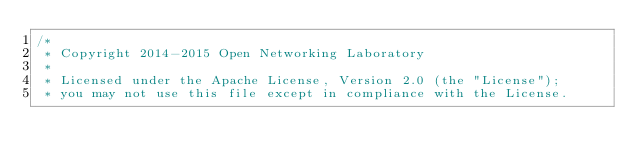<code> <loc_0><loc_0><loc_500><loc_500><_Java_>/*
 * Copyright 2014-2015 Open Networking Laboratory
 *
 * Licensed under the Apache License, Version 2.0 (the "License");
 * you may not use this file except in compliance with the License.</code> 